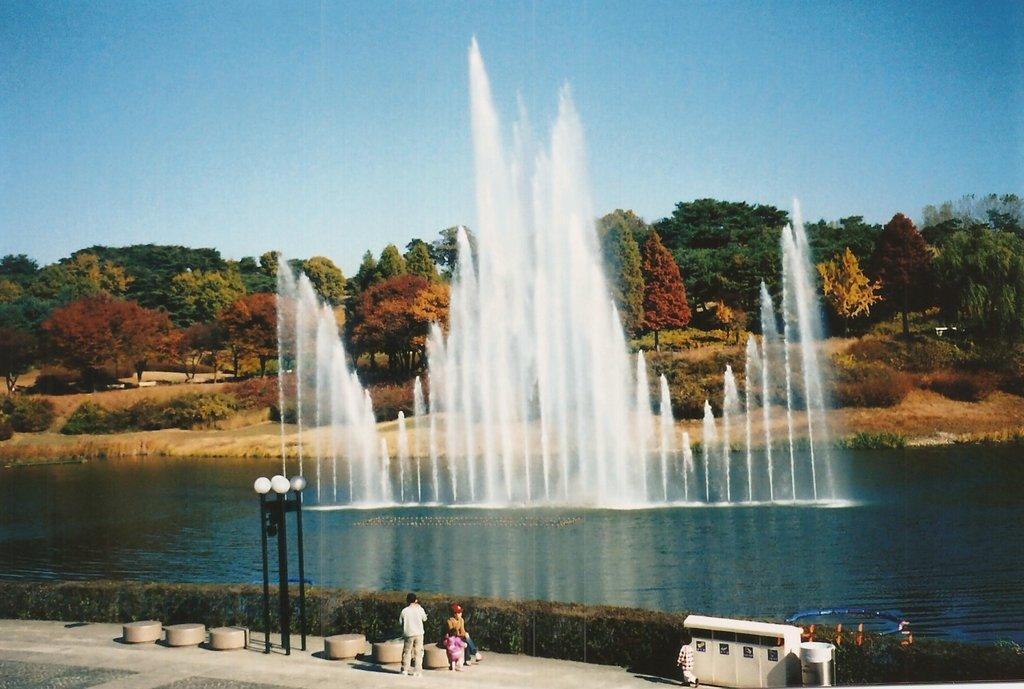Could you give a brief overview of what you see in this image? In this image I can see a person wearing white shirt, grey pant is standing and few other persons are sitting. I can see few poles which are black in color and on the top of them I can see white colored lights. In the background I can see the water, the fountain, few trees and the sky. 